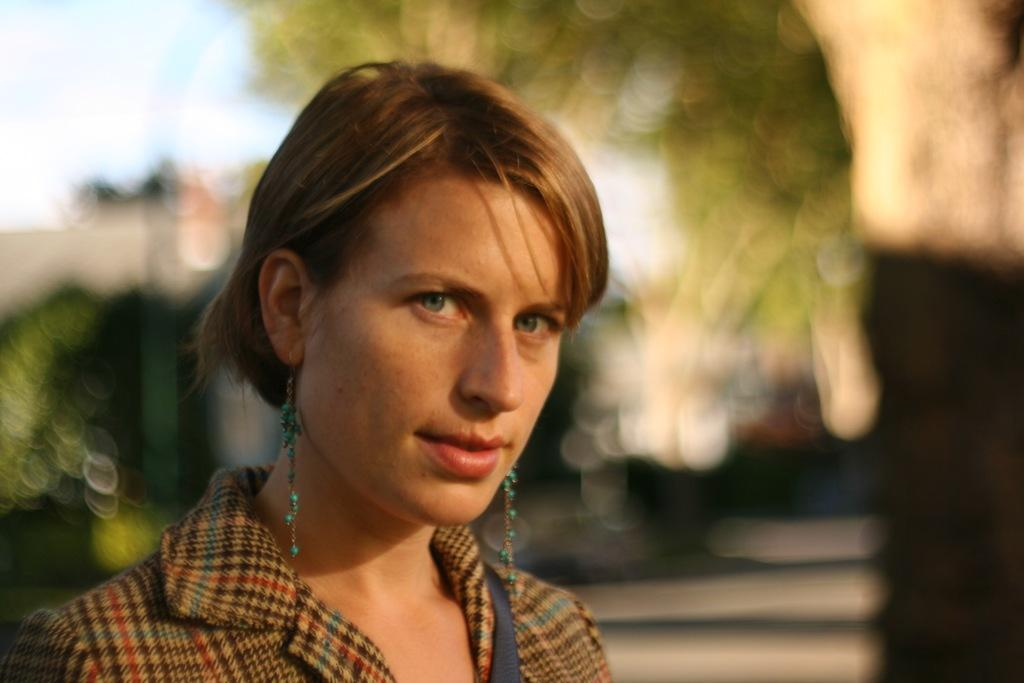What can be seen in the image? There is a person in the image. Can you describe the person's appearance? The person is wearing long earrings and a sling bag. What can be observed about the background of the image? The background of the image is blurred. What type of print can be seen on the crayon in the image? There is no crayon present in the image, so it is not possible to determine the type of print on it. 